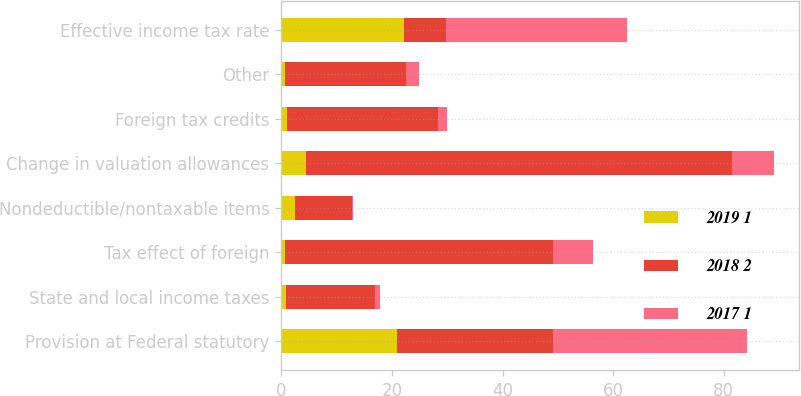Convert chart. <chart><loc_0><loc_0><loc_500><loc_500><stacked_bar_chart><ecel><fcel>Provision at Federal statutory<fcel>State and local income taxes<fcel>Tax effect of foreign<fcel>Nondeductible/nontaxable items<fcel>Change in valuation allowances<fcel>Foreign tax credits<fcel>Other<fcel>Effective income tax rate<nl><fcel>2019 1<fcel>21<fcel>0.9<fcel>0.7<fcel>2.5<fcel>4.5<fcel>1<fcel>0.7<fcel>22.1<nl><fcel>2018 2<fcel>28.1<fcel>16<fcel>48.4<fcel>10.2<fcel>76.9<fcel>27.3<fcel>21.9<fcel>7.7<nl><fcel>2017 1<fcel>35<fcel>1<fcel>7.3<fcel>0.2<fcel>7.7<fcel>1.6<fcel>2.3<fcel>32.7<nl></chart> 